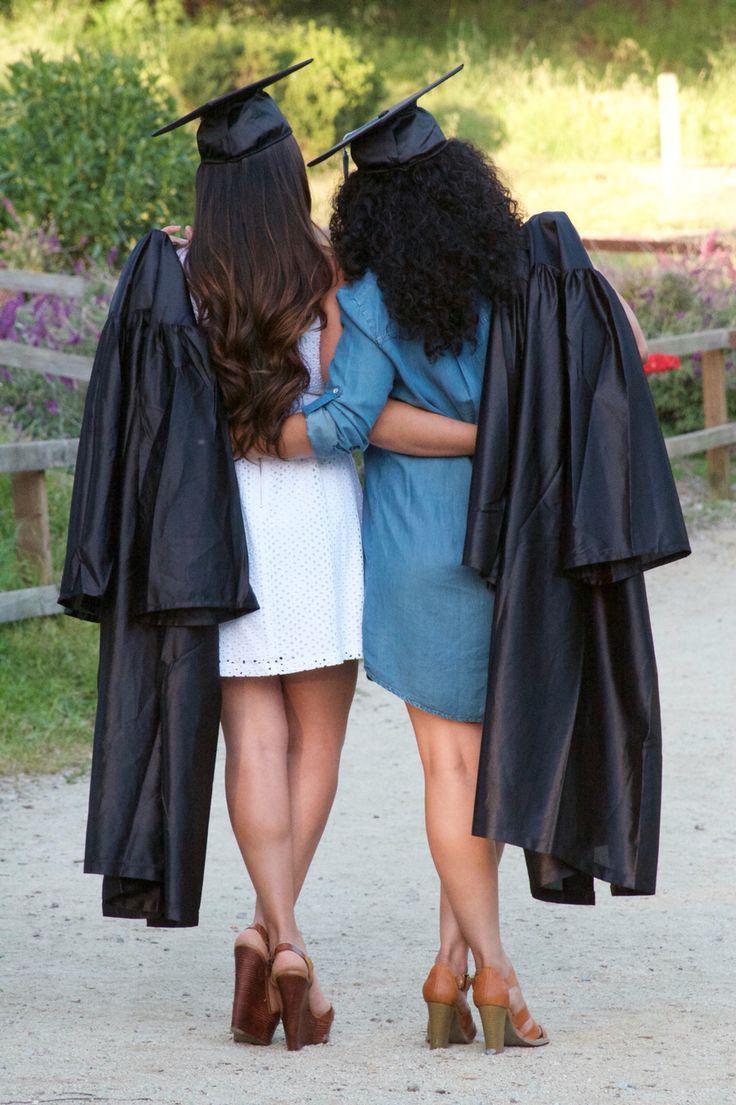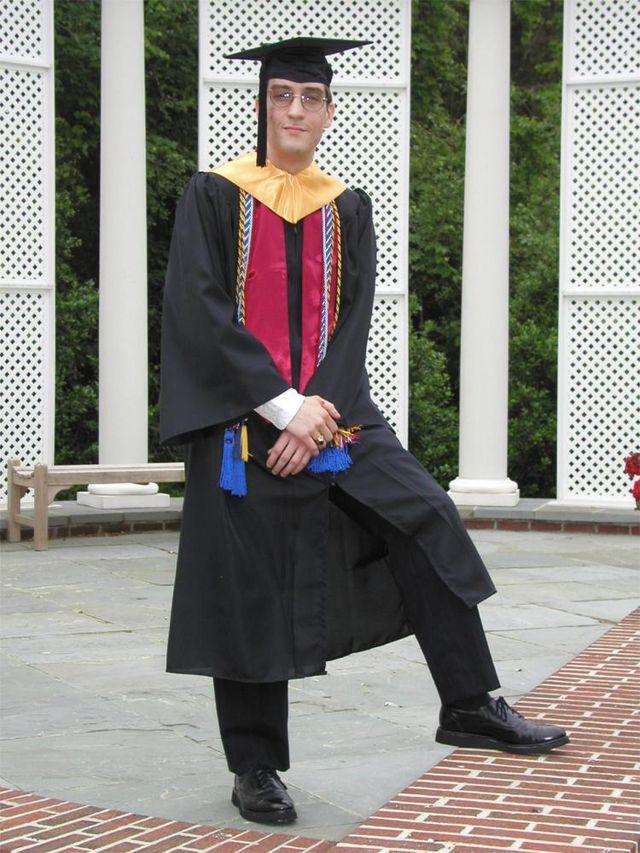The first image is the image on the left, the second image is the image on the right. Evaluate the accuracy of this statement regarding the images: "In one of the images, there is only one person, and they are facing away from the camera.". Is it true? Answer yes or no. No. The first image is the image on the left, the second image is the image on the right. Considering the images on both sides, is "The graduate in the left image can be seen smiling." valid? Answer yes or no. No. 